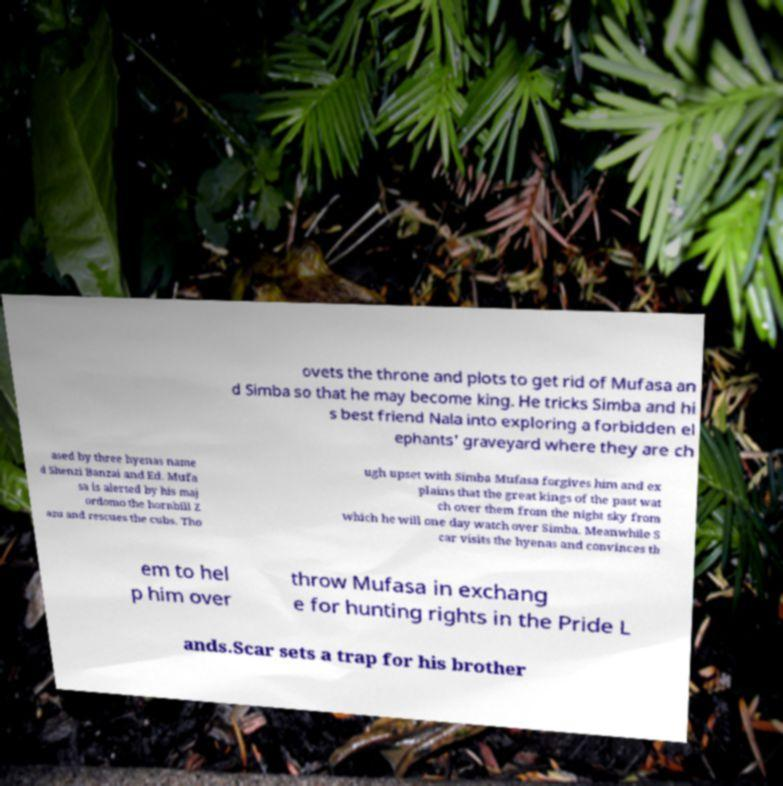I need the written content from this picture converted into text. Can you do that? ovets the throne and plots to get rid of Mufasa an d Simba so that he may become king. He tricks Simba and hi s best friend Nala into exploring a forbidden el ephants' graveyard where they are ch ased by three hyenas name d Shenzi Banzai and Ed. Mufa sa is alerted by his maj ordomo the hornbill Z azu and rescues the cubs. Tho ugh upset with Simba Mufasa forgives him and ex plains that the great kings of the past wat ch over them from the night sky from which he will one day watch over Simba. Meanwhile S car visits the hyenas and convinces th em to hel p him over throw Mufasa in exchang e for hunting rights in the Pride L ands.Scar sets a trap for his brother 